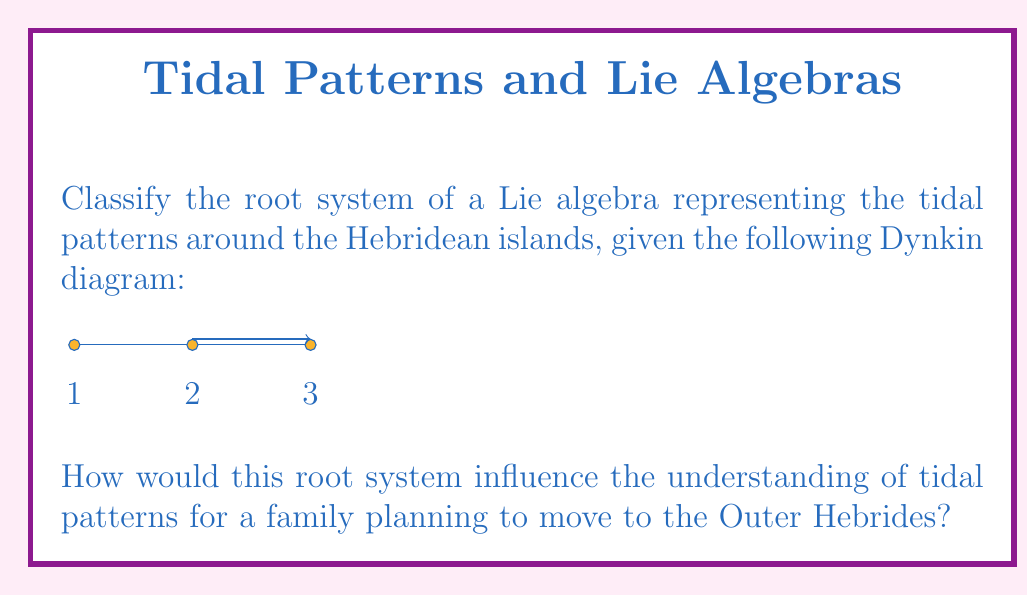Can you answer this question? To classify the root system and understand its implications for tidal patterns, let's follow these steps:

1) The given Dynkin diagram represents a rank-3 Lie algebra. The arrow between nodes 2 and 3 indicates that this is not a simply-laced algebra.

2) The structure of the diagram matches that of the $C_3$ Lie algebra, which is associated with the symplectic group $Sp(6)$.

3) The $C_3$ root system has the following properties:
   - Total number of roots: $18$
   - Number of positive roots: $9$
   - Highest root: $\alpha_1 + 2\alpha_2 + 2\alpha_3$

4) In the context of tidal patterns:
   - The three nodes can represent three primary factors influencing tides: lunar phase, solar influence, and local topography.
   - The arrow indicates a stronger influence of local topography (node 3) on the solar influence (node 2) than vice versa.

5) The $C_3$ system suggests a complex interplay between these factors:
   - Short roots (±$\alpha_1$, ±$\alpha_2$, ±$\alpha_3$) represent basic tidal cycles.
   - Medium roots (±($\alpha_1 + \alpha_2$), ±($\alpha_2 + \alpha_3$), ±($\alpha_1 + \alpha_2 + \alpha_3$)) represent compound effects.
   - Long roots (±$2\alpha_3$, ±($\alpha_2 + 2\alpha_3$), ±($\alpha_1 + \alpha_2 + 2\alpha_3$)) represent enhanced effects of local topography.

6) For a family moving to the Outer Hebrides:
   - The $C_3$ system implies a more complex tidal pattern than a simpler $A_3$ system would suggest.
   - The long roots associated with $\alpha_3$ indicate that local topography plays a significant role in modifying tidal behavior.
   - This suggests the need for careful observation and local knowledge to predict tides accurately, as they may vary significantly between different islands or coastal areas.
Answer: $C_3$ root system; implies complex tidal patterns with strong local topographic influence. 